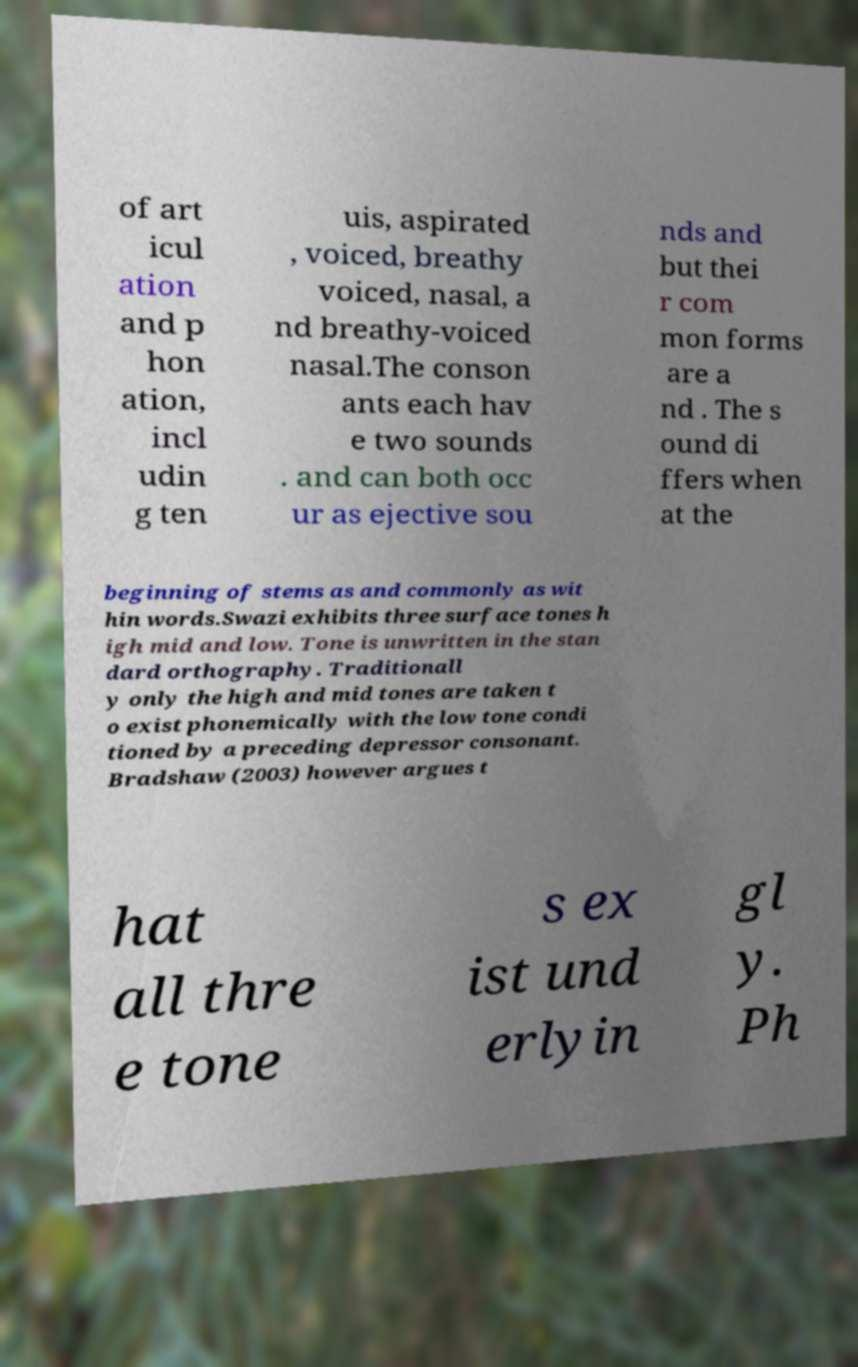Can you read and provide the text displayed in the image?This photo seems to have some interesting text. Can you extract and type it out for me? of art icul ation and p hon ation, incl udin g ten uis, aspirated , voiced, breathy voiced, nasal, a nd breathy-voiced nasal.The conson ants each hav e two sounds . and can both occ ur as ejective sou nds and but thei r com mon forms are a nd . The s ound di ffers when at the beginning of stems as and commonly as wit hin words.Swazi exhibits three surface tones h igh mid and low. Tone is unwritten in the stan dard orthography. Traditionall y only the high and mid tones are taken t o exist phonemically with the low tone condi tioned by a preceding depressor consonant. Bradshaw (2003) however argues t hat all thre e tone s ex ist und erlyin gl y. Ph 